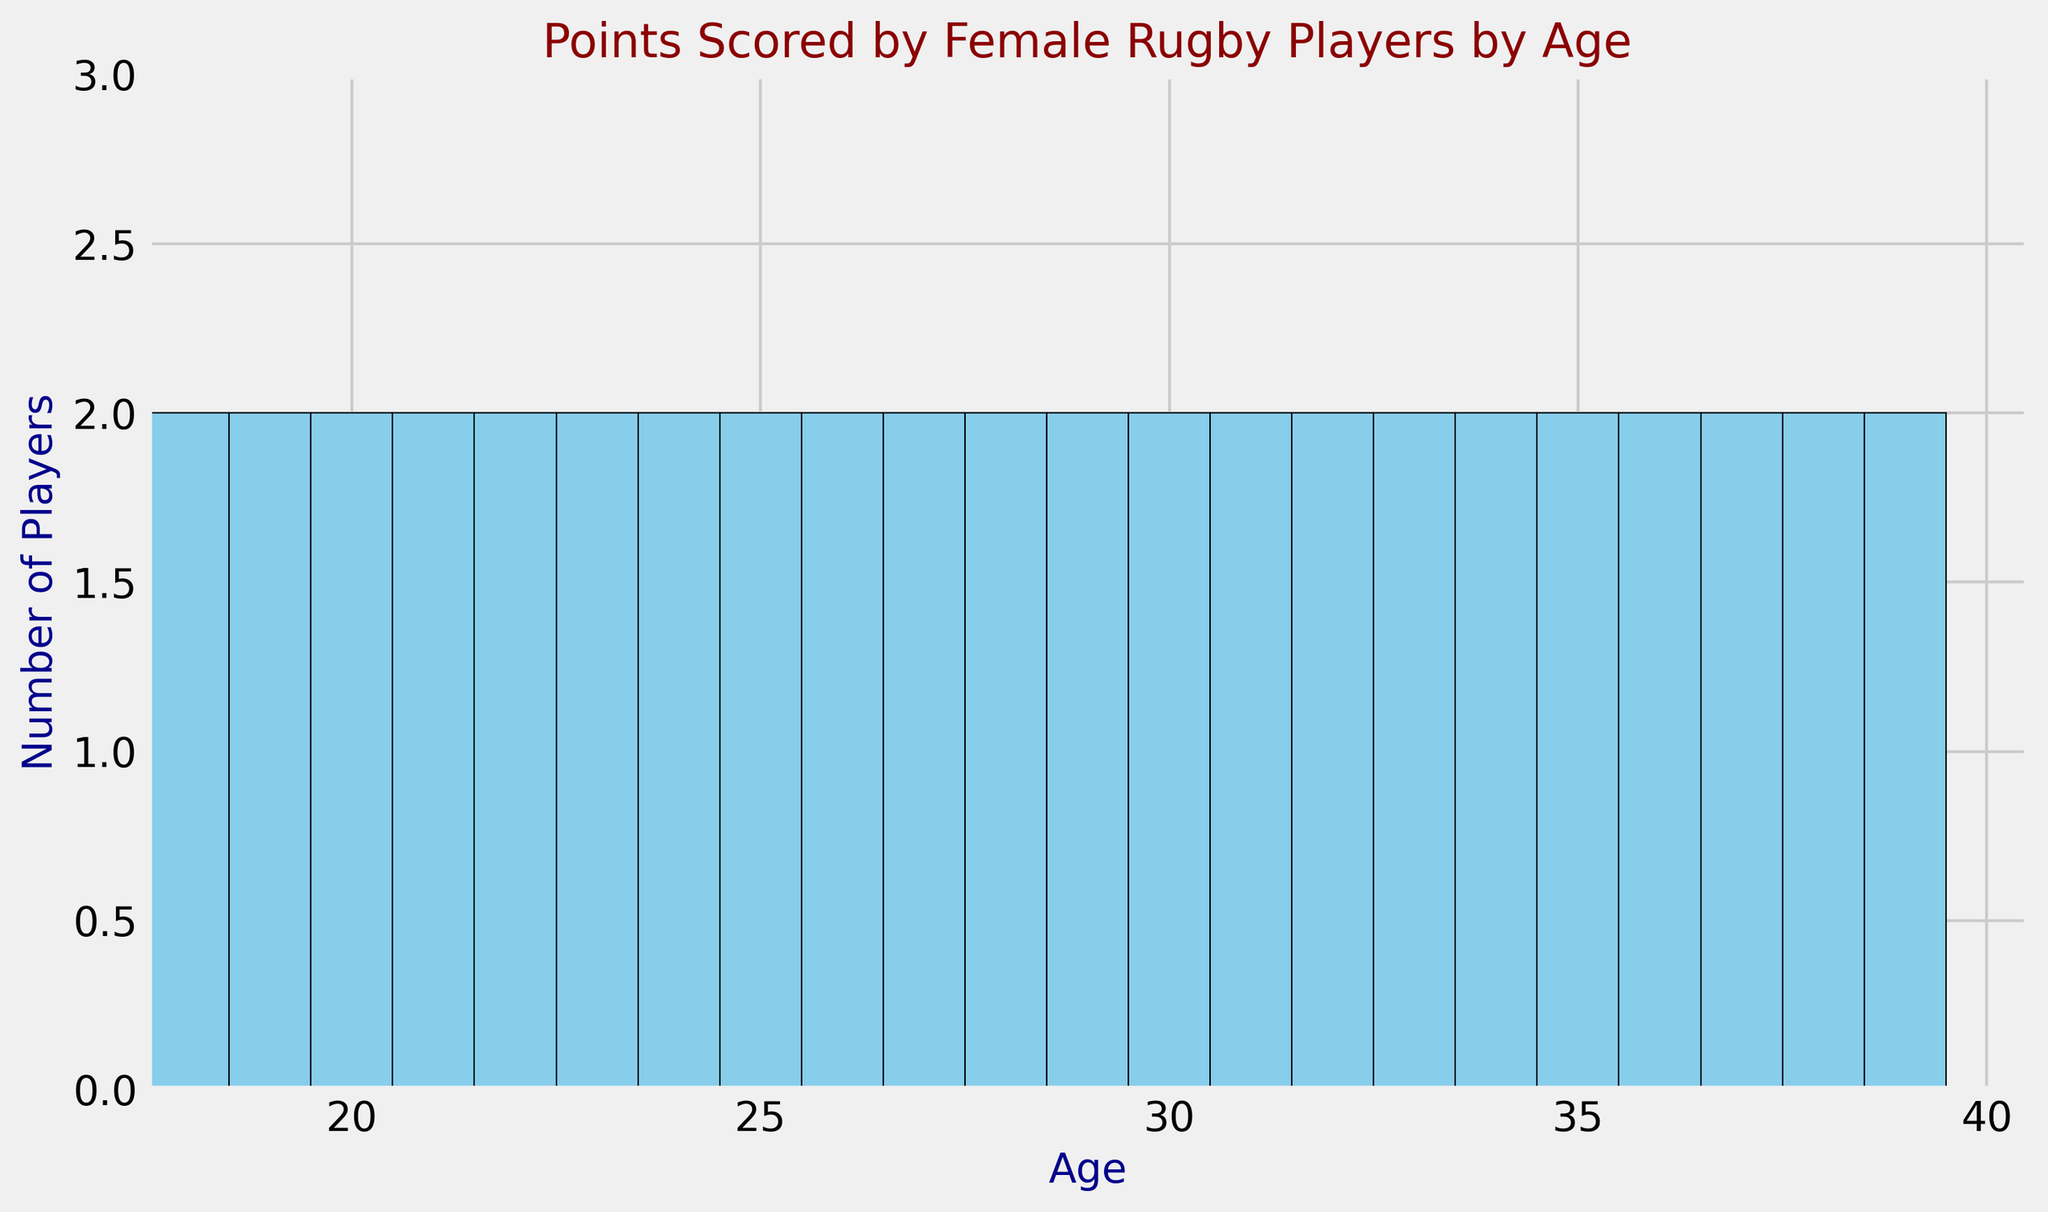What's the age group with the highest number of players? The histogram displays the frequency of players for each age group. The tallest bar represents the age group with the highest number of players.
Answer: 40 How many players are in the 25 to 30 age range? Sum the heights of the bars representing ages 25, 26, 27, 28, 29, and 30. The histogram shows the frequency for each of these ages, each being 2 players.
Answer: 12 Is there any age group that has exactly one player? Scan the histogram bars to see if there's any bar with a height of 1 player. All bars have at least 2 players.
Answer: No At what age do players start scoring progressively higher points starting from age 30? Review the histogram section from age 30 onwards; heights of bars remain constant at 2 players for each age group. This indicates the start of consistent higher points scored around age 30.
Answer: 30 Which age group shows a balance with exactly 4 players contributing points? Evaluate the histogram to find any age group where the height of the bar is 4. No age group has a height of 4 players.
Answer: None Between 18 to 24 years and 32 to 38 years, which age group has more players? Count the total bars' heights from ages 18 to 24 and compare with the total bars' heights from ages 32 to 38: (5+5+5+5+5+5=30) vs. (2+2+2+2+2+2+2=14).
Answer: 18 to 24 years Is there more variability in the number of players in the younger age group (18-24) or the older age group (35-40)? Compare the bars' heights in each age range. The 18-24 age group has more variability with heights varying from 1 player (age 18-19) to 2 players (age 20-24), while 35-40 age group consistently has 2 players.
Answer: Younger age group (18-24) Which age has the lowest representation of players? Identify the shortest bars in the histogram, representing the age group with the fewest players. The shortest bar corresponds to ages 18 and 19 with 1 player each.
Answer: 18 and 19 What is the most common number of players for an age group in this data? Examine the histogram and observe the most frequent height of the bars, which is the mode. Bars often have a height of 2 players for most age groups.
Answer: 2 